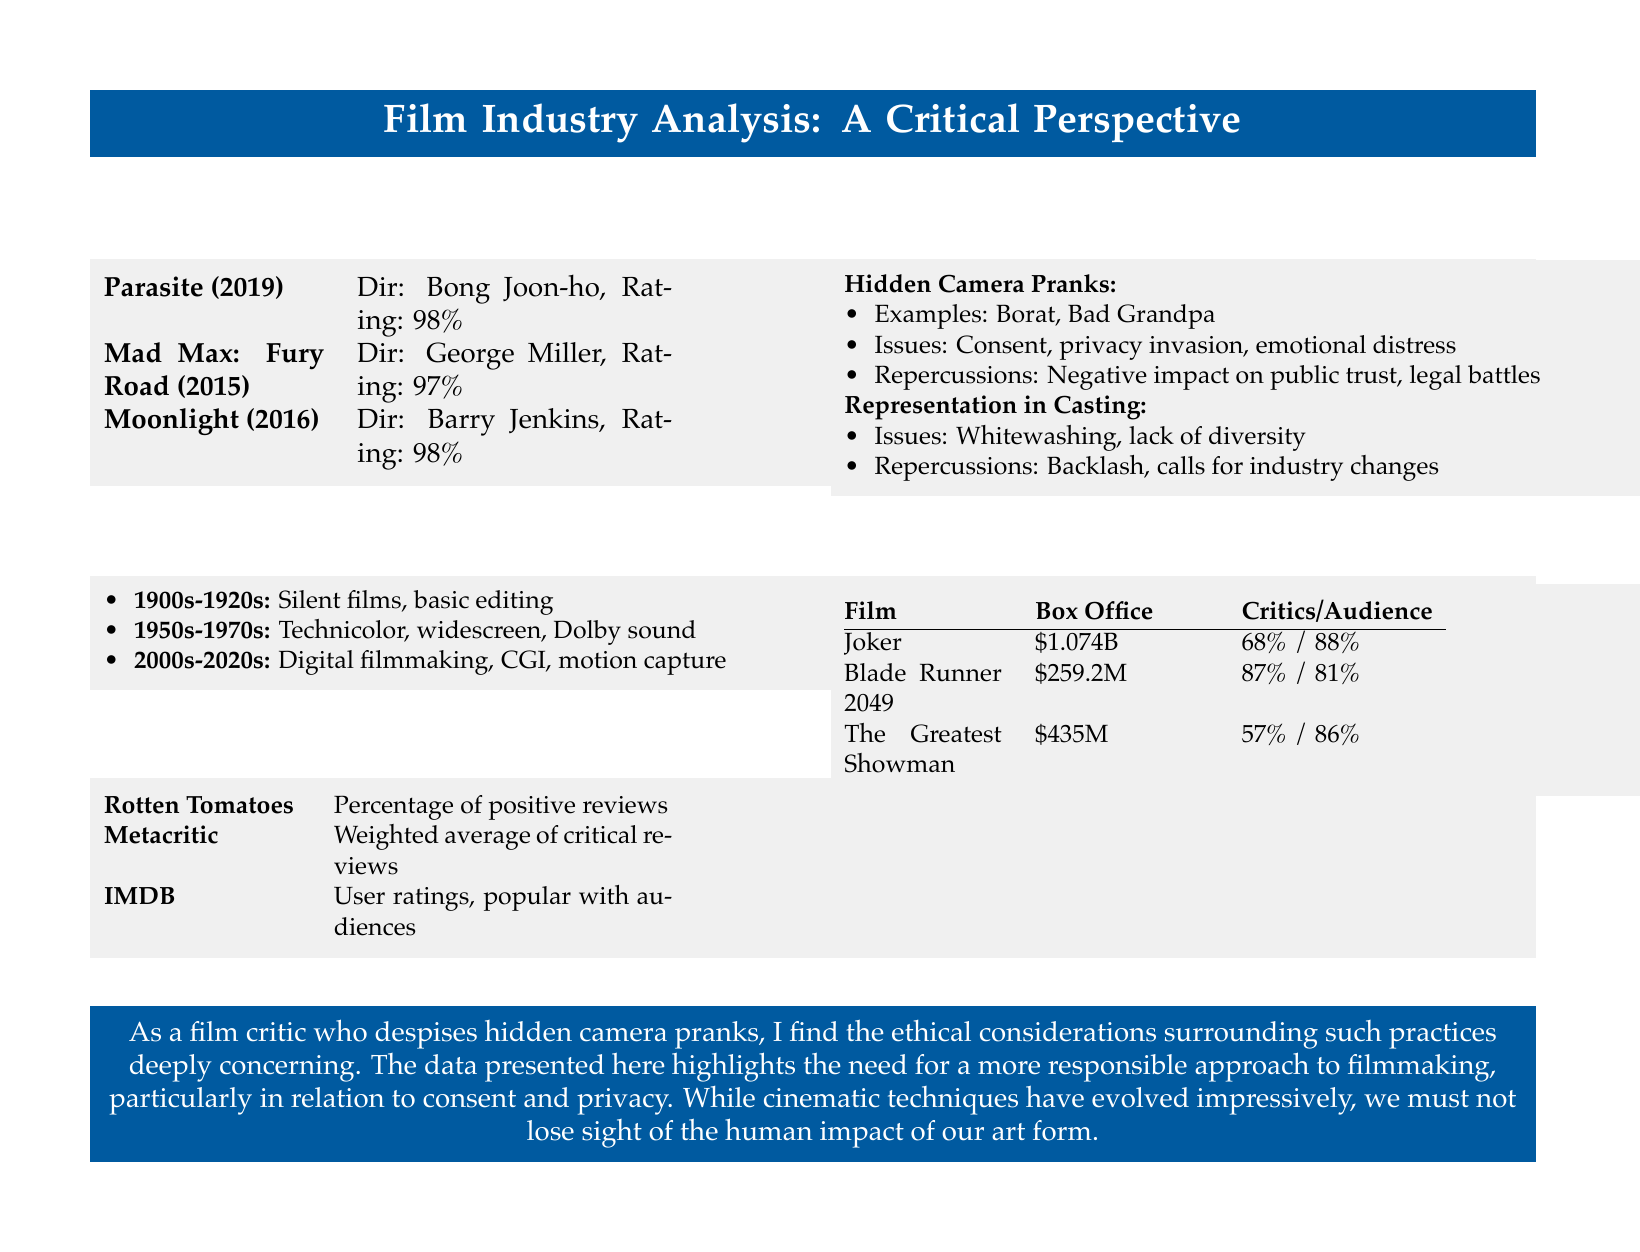What is the highest rating among the films listed? The highest rating among the films listed in the top critically acclaimed films section is 98%.
Answer: 98% Who directed Mad Max: Fury Road? The director of Mad Max: Fury Road, as stated in the document, is George Miller.
Answer: George Miller What is a significant issue related to hidden camera pranks mentioned in the document? The document highlights consent as a significant issue related to hidden camera pranks.
Answer: Consent Which film earned the highest box office revenue? According to the box office vs. critical reception section, Joker earned the highest box office revenue at $1.074 billion.
Answer: $1.074B What type of films does the ethical considerations section focus on? The ethical considerations section focuses on hidden camera pranks and their repercussions.
Answer: Hidden camera pranks Which film received the lowest critical rating among those listed? The Greatest Showman received the lowest critical rating among those listed with 57%.
Answer: 57% What technological advancement is noted in the evolution of cinematic techniques? Digital filmmaking is noted as a technological advancement in the evolution of cinematic techniques.
Answer: Digital filmmaking Which film received the highest audience score? According to the box office vs. critical reception section, Joker received the highest audience score of 88%.
Answer: 88% 